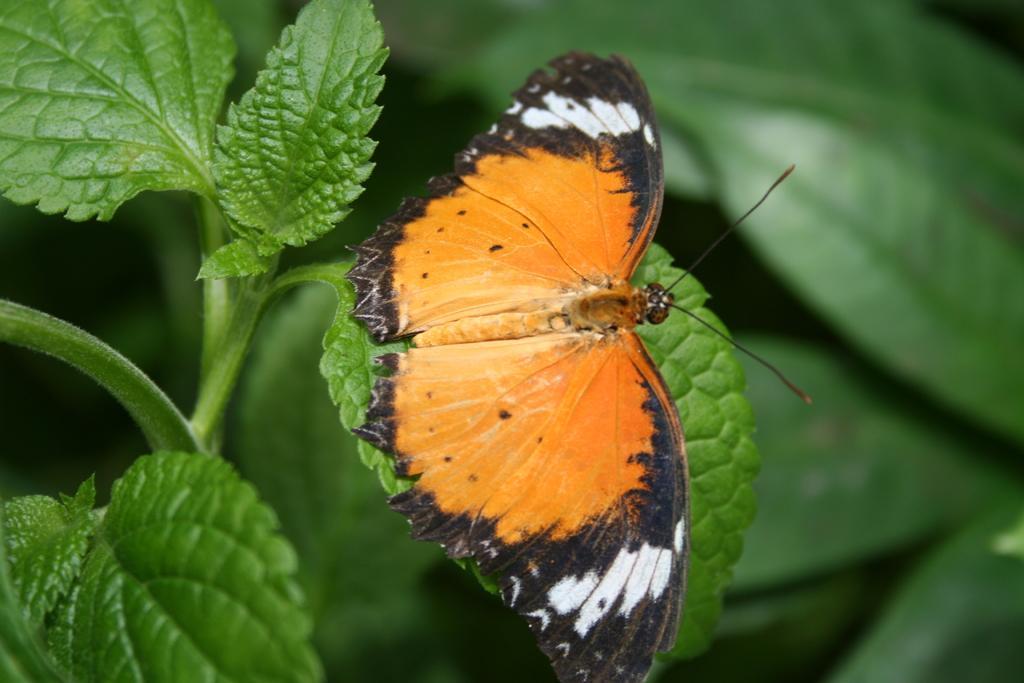Can you describe this image briefly? In this image there is a butterfly on the leaf of a plant. 